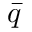<formula> <loc_0><loc_0><loc_500><loc_500>\bar { q }</formula> 